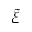Convert formula to latex. <formula><loc_0><loc_0><loc_500><loc_500>\tilde { \xi }</formula> 